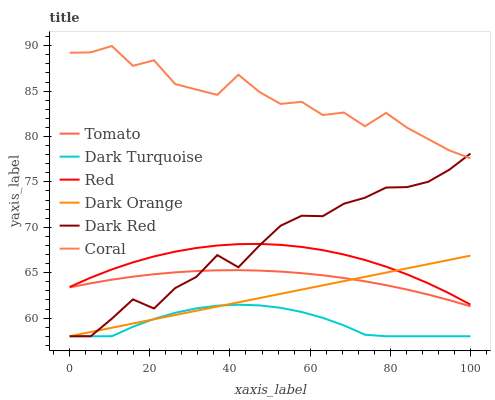Does Dark Turquoise have the minimum area under the curve?
Answer yes or no. Yes. Does Coral have the maximum area under the curve?
Answer yes or no. Yes. Does Dark Orange have the minimum area under the curve?
Answer yes or no. No. Does Dark Orange have the maximum area under the curve?
Answer yes or no. No. Is Dark Orange the smoothest?
Answer yes or no. Yes. Is Coral the roughest?
Answer yes or no. Yes. Is Dark Turquoise the smoothest?
Answer yes or no. No. Is Dark Turquoise the roughest?
Answer yes or no. No. Does Coral have the lowest value?
Answer yes or no. No. Does Coral have the highest value?
Answer yes or no. Yes. Does Dark Orange have the highest value?
Answer yes or no. No. Is Dark Orange less than Coral?
Answer yes or no. Yes. Is Tomato greater than Dark Turquoise?
Answer yes or no. Yes. Does Tomato intersect Dark Red?
Answer yes or no. Yes. Is Tomato less than Dark Red?
Answer yes or no. No. Is Tomato greater than Dark Red?
Answer yes or no. No. Does Dark Orange intersect Coral?
Answer yes or no. No. 